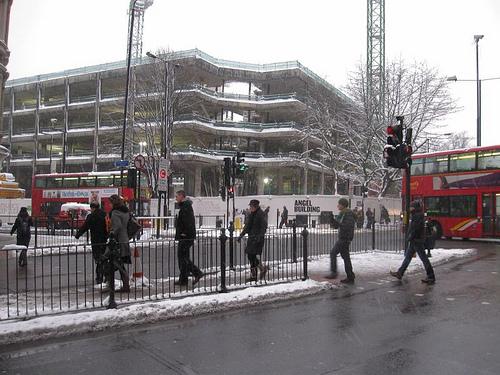Is it cold?
Write a very short answer. Yes. What country is this?
Answer briefly. London. What season is it in the picture?
Give a very brief answer. Winter. What season is it?
Concise answer only. Winter. 